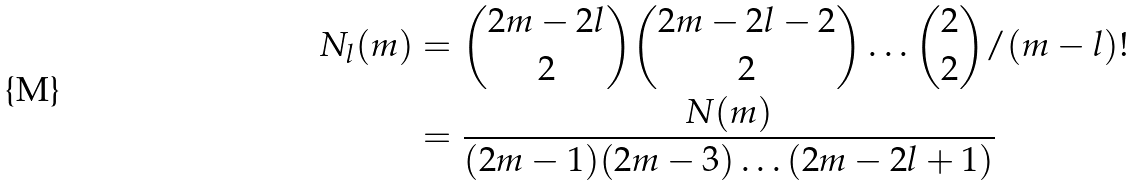<formula> <loc_0><loc_0><loc_500><loc_500>N _ { l } ( m ) & = \binom { 2 m - 2 l } { 2 } \binom { 2 m - 2 l - 2 } { 2 } \dots \binom { 2 } { 2 } / ( m - l ) ! \\ & = \frac { N ( m ) } { ( 2 m - 1 ) ( 2 m - 3 ) \dots ( 2 m - 2 l + 1 ) } \\</formula> 